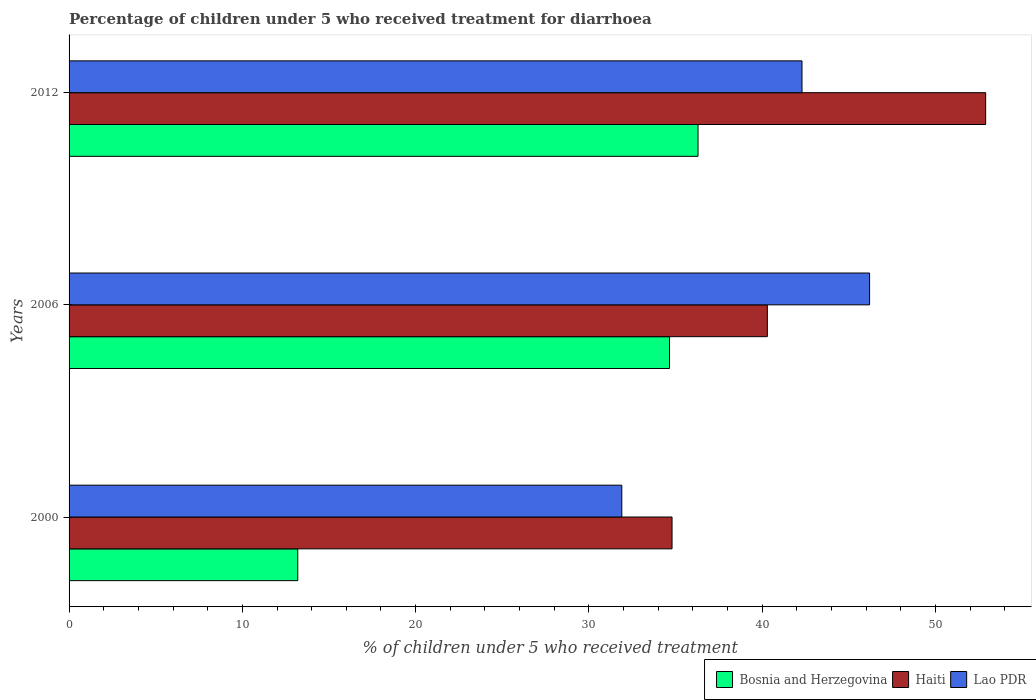How many different coloured bars are there?
Offer a terse response. 3. Are the number of bars on each tick of the Y-axis equal?
Your answer should be very brief. Yes. What is the label of the 3rd group of bars from the top?
Your response must be concise. 2000. In how many cases, is the number of bars for a given year not equal to the number of legend labels?
Your answer should be very brief. 0. What is the percentage of children who received treatment for diarrhoea  in Bosnia and Herzegovina in 2012?
Ensure brevity in your answer.  36.3. Across all years, what is the maximum percentage of children who received treatment for diarrhoea  in Lao PDR?
Keep it short and to the point. 46.2. Across all years, what is the minimum percentage of children who received treatment for diarrhoea  in Haiti?
Your answer should be very brief. 34.8. In which year was the percentage of children who received treatment for diarrhoea  in Bosnia and Herzegovina maximum?
Ensure brevity in your answer.  2012. What is the total percentage of children who received treatment for diarrhoea  in Bosnia and Herzegovina in the graph?
Keep it short and to the point. 84.15. What is the difference between the percentage of children who received treatment for diarrhoea  in Bosnia and Herzegovina in 2000 and that in 2012?
Your response must be concise. -23.1. What is the difference between the percentage of children who received treatment for diarrhoea  in Bosnia and Herzegovina in 2006 and the percentage of children who received treatment for diarrhoea  in Lao PDR in 2012?
Your response must be concise. -7.65. What is the average percentage of children who received treatment for diarrhoea  in Bosnia and Herzegovina per year?
Your response must be concise. 28.05. In the year 2006, what is the difference between the percentage of children who received treatment for diarrhoea  in Bosnia and Herzegovina and percentage of children who received treatment for diarrhoea  in Haiti?
Make the answer very short. -5.65. In how many years, is the percentage of children who received treatment for diarrhoea  in Haiti greater than 32 %?
Offer a terse response. 3. What is the ratio of the percentage of children who received treatment for diarrhoea  in Haiti in 2000 to that in 2006?
Keep it short and to the point. 0.86. Is the percentage of children who received treatment for diarrhoea  in Lao PDR in 2000 less than that in 2006?
Offer a very short reply. Yes. Is the difference between the percentage of children who received treatment for diarrhoea  in Bosnia and Herzegovina in 2006 and 2012 greater than the difference between the percentage of children who received treatment for diarrhoea  in Haiti in 2006 and 2012?
Give a very brief answer. Yes. What is the difference between the highest and the second highest percentage of children who received treatment for diarrhoea  in Haiti?
Offer a very short reply. 12.6. What is the difference between the highest and the lowest percentage of children who received treatment for diarrhoea  in Haiti?
Provide a succinct answer. 18.1. What does the 3rd bar from the top in 2012 represents?
Offer a very short reply. Bosnia and Herzegovina. What does the 1st bar from the bottom in 2000 represents?
Your response must be concise. Bosnia and Herzegovina. How many bars are there?
Make the answer very short. 9. What is the difference between two consecutive major ticks on the X-axis?
Make the answer very short. 10. Does the graph contain any zero values?
Make the answer very short. No. Does the graph contain grids?
Offer a terse response. No. Where does the legend appear in the graph?
Your answer should be compact. Bottom right. How many legend labels are there?
Your answer should be compact. 3. What is the title of the graph?
Keep it short and to the point. Percentage of children under 5 who received treatment for diarrhoea. What is the label or title of the X-axis?
Offer a terse response. % of children under 5 who received treatment. What is the % of children under 5 who received treatment in Bosnia and Herzegovina in 2000?
Offer a terse response. 13.2. What is the % of children under 5 who received treatment of Haiti in 2000?
Ensure brevity in your answer.  34.8. What is the % of children under 5 who received treatment in Lao PDR in 2000?
Provide a short and direct response. 31.9. What is the % of children under 5 who received treatment in Bosnia and Herzegovina in 2006?
Give a very brief answer. 34.65. What is the % of children under 5 who received treatment in Haiti in 2006?
Offer a very short reply. 40.3. What is the % of children under 5 who received treatment in Lao PDR in 2006?
Offer a very short reply. 46.2. What is the % of children under 5 who received treatment of Bosnia and Herzegovina in 2012?
Provide a short and direct response. 36.3. What is the % of children under 5 who received treatment in Haiti in 2012?
Your response must be concise. 52.9. What is the % of children under 5 who received treatment of Lao PDR in 2012?
Your response must be concise. 42.3. Across all years, what is the maximum % of children under 5 who received treatment of Bosnia and Herzegovina?
Offer a terse response. 36.3. Across all years, what is the maximum % of children under 5 who received treatment of Haiti?
Your response must be concise. 52.9. Across all years, what is the maximum % of children under 5 who received treatment in Lao PDR?
Provide a short and direct response. 46.2. Across all years, what is the minimum % of children under 5 who received treatment in Haiti?
Your response must be concise. 34.8. Across all years, what is the minimum % of children under 5 who received treatment of Lao PDR?
Your response must be concise. 31.9. What is the total % of children under 5 who received treatment of Bosnia and Herzegovina in the graph?
Your answer should be compact. 84.15. What is the total % of children under 5 who received treatment in Haiti in the graph?
Your answer should be very brief. 128. What is the total % of children under 5 who received treatment in Lao PDR in the graph?
Make the answer very short. 120.4. What is the difference between the % of children under 5 who received treatment in Bosnia and Herzegovina in 2000 and that in 2006?
Give a very brief answer. -21.45. What is the difference between the % of children under 5 who received treatment in Haiti in 2000 and that in 2006?
Provide a short and direct response. -5.5. What is the difference between the % of children under 5 who received treatment of Lao PDR in 2000 and that in 2006?
Your answer should be compact. -14.3. What is the difference between the % of children under 5 who received treatment of Bosnia and Herzegovina in 2000 and that in 2012?
Provide a succinct answer. -23.1. What is the difference between the % of children under 5 who received treatment of Haiti in 2000 and that in 2012?
Offer a very short reply. -18.1. What is the difference between the % of children under 5 who received treatment in Bosnia and Herzegovina in 2006 and that in 2012?
Provide a succinct answer. -1.65. What is the difference between the % of children under 5 who received treatment in Bosnia and Herzegovina in 2000 and the % of children under 5 who received treatment in Haiti in 2006?
Offer a very short reply. -27.1. What is the difference between the % of children under 5 who received treatment of Bosnia and Herzegovina in 2000 and the % of children under 5 who received treatment of Lao PDR in 2006?
Keep it short and to the point. -33. What is the difference between the % of children under 5 who received treatment of Bosnia and Herzegovina in 2000 and the % of children under 5 who received treatment of Haiti in 2012?
Keep it short and to the point. -39.7. What is the difference between the % of children under 5 who received treatment of Bosnia and Herzegovina in 2000 and the % of children under 5 who received treatment of Lao PDR in 2012?
Your answer should be compact. -29.1. What is the difference between the % of children under 5 who received treatment of Haiti in 2000 and the % of children under 5 who received treatment of Lao PDR in 2012?
Offer a terse response. -7.5. What is the difference between the % of children under 5 who received treatment of Bosnia and Herzegovina in 2006 and the % of children under 5 who received treatment of Haiti in 2012?
Provide a succinct answer. -18.25. What is the difference between the % of children under 5 who received treatment in Bosnia and Herzegovina in 2006 and the % of children under 5 who received treatment in Lao PDR in 2012?
Your answer should be compact. -7.65. What is the difference between the % of children under 5 who received treatment in Haiti in 2006 and the % of children under 5 who received treatment in Lao PDR in 2012?
Provide a short and direct response. -2. What is the average % of children under 5 who received treatment in Bosnia and Herzegovina per year?
Offer a very short reply. 28.05. What is the average % of children under 5 who received treatment of Haiti per year?
Ensure brevity in your answer.  42.67. What is the average % of children under 5 who received treatment in Lao PDR per year?
Keep it short and to the point. 40.13. In the year 2000, what is the difference between the % of children under 5 who received treatment in Bosnia and Herzegovina and % of children under 5 who received treatment in Haiti?
Offer a terse response. -21.6. In the year 2000, what is the difference between the % of children under 5 who received treatment of Bosnia and Herzegovina and % of children under 5 who received treatment of Lao PDR?
Provide a succinct answer. -18.7. In the year 2006, what is the difference between the % of children under 5 who received treatment in Bosnia and Herzegovina and % of children under 5 who received treatment in Haiti?
Ensure brevity in your answer.  -5.65. In the year 2006, what is the difference between the % of children under 5 who received treatment in Bosnia and Herzegovina and % of children under 5 who received treatment in Lao PDR?
Your response must be concise. -11.55. In the year 2012, what is the difference between the % of children under 5 who received treatment of Bosnia and Herzegovina and % of children under 5 who received treatment of Haiti?
Provide a short and direct response. -16.6. In the year 2012, what is the difference between the % of children under 5 who received treatment in Bosnia and Herzegovina and % of children under 5 who received treatment in Lao PDR?
Make the answer very short. -6. What is the ratio of the % of children under 5 who received treatment in Bosnia and Herzegovina in 2000 to that in 2006?
Your response must be concise. 0.38. What is the ratio of the % of children under 5 who received treatment in Haiti in 2000 to that in 2006?
Ensure brevity in your answer.  0.86. What is the ratio of the % of children under 5 who received treatment of Lao PDR in 2000 to that in 2006?
Make the answer very short. 0.69. What is the ratio of the % of children under 5 who received treatment in Bosnia and Herzegovina in 2000 to that in 2012?
Make the answer very short. 0.36. What is the ratio of the % of children under 5 who received treatment of Haiti in 2000 to that in 2012?
Provide a succinct answer. 0.66. What is the ratio of the % of children under 5 who received treatment in Lao PDR in 2000 to that in 2012?
Provide a succinct answer. 0.75. What is the ratio of the % of children under 5 who received treatment in Bosnia and Herzegovina in 2006 to that in 2012?
Give a very brief answer. 0.95. What is the ratio of the % of children under 5 who received treatment in Haiti in 2006 to that in 2012?
Your answer should be compact. 0.76. What is the ratio of the % of children under 5 who received treatment of Lao PDR in 2006 to that in 2012?
Ensure brevity in your answer.  1.09. What is the difference between the highest and the second highest % of children under 5 who received treatment in Bosnia and Herzegovina?
Your answer should be very brief. 1.65. What is the difference between the highest and the second highest % of children under 5 who received treatment of Haiti?
Offer a terse response. 12.6. What is the difference between the highest and the second highest % of children under 5 who received treatment of Lao PDR?
Keep it short and to the point. 3.9. What is the difference between the highest and the lowest % of children under 5 who received treatment in Bosnia and Herzegovina?
Your answer should be compact. 23.1. What is the difference between the highest and the lowest % of children under 5 who received treatment in Haiti?
Give a very brief answer. 18.1. What is the difference between the highest and the lowest % of children under 5 who received treatment in Lao PDR?
Offer a very short reply. 14.3. 